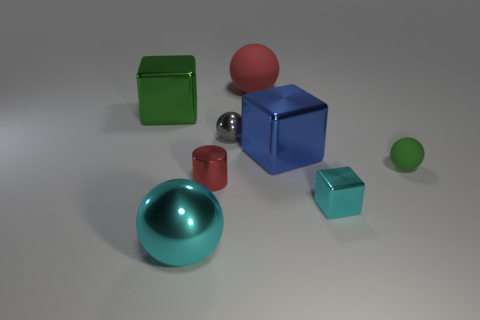There is a sphere to the right of the large ball behind the tiny green matte ball that is right of the red cylinder; what is it made of?
Ensure brevity in your answer.  Rubber. Is the number of green objects behind the big metal sphere greater than the number of tiny cyan blocks?
Provide a short and direct response. Yes. There is a green object that is the same size as the cyan block; what is its material?
Ensure brevity in your answer.  Rubber. Are there any cyan shiny objects that have the same size as the green ball?
Make the answer very short. Yes. What size is the metallic object in front of the small block?
Ensure brevity in your answer.  Large. How big is the red rubber ball?
Make the answer very short. Large. What number of balls are large red things or big cyan things?
Your answer should be compact. 2. There is a green thing that is the same material as the gray sphere; what is its size?
Offer a terse response. Large. How many small spheres are the same color as the cylinder?
Offer a very short reply. 0. Are there any tiny red metal cylinders to the right of the small shiny cube?
Provide a short and direct response. No. 